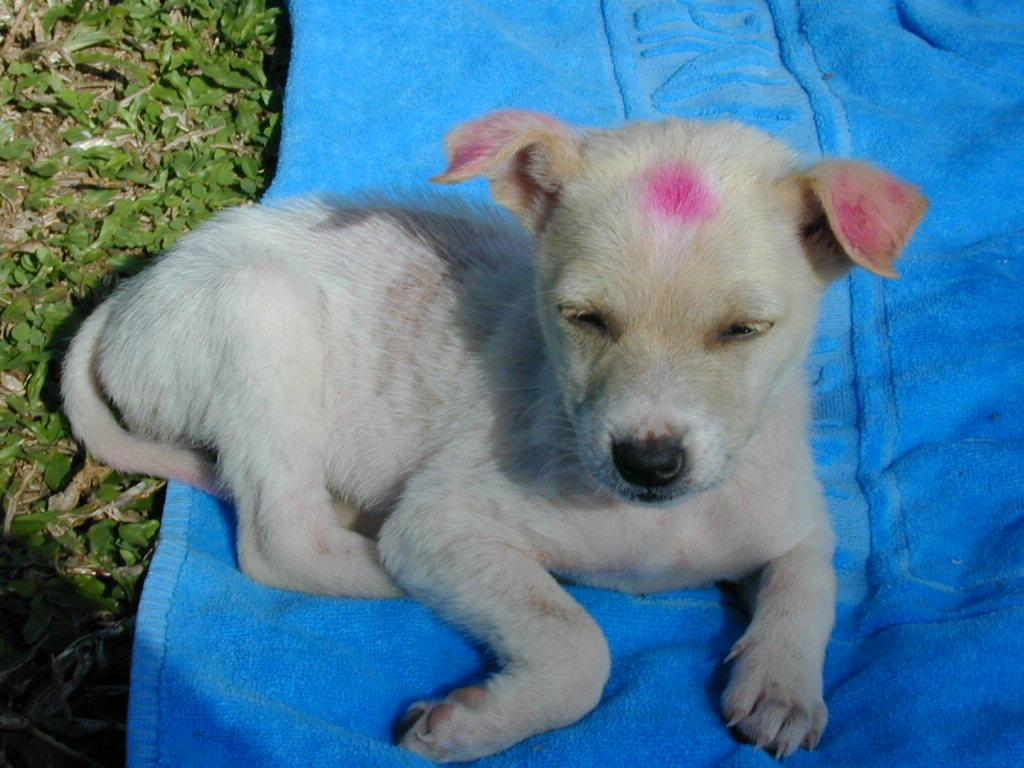What type of animal is in the image? There is a white color puppy in the image. What is the puppy laying on? The puppy is laying on a blue color cloth. Where is the cloth placed? The cloth is placed on the ground. What can be seen on the ground on the left side of the image? There are leaves on the ground on the left side of the image. What type of sponge is being used by the puppy to sleep in the image? There is no sponge present in the image, and the puppy is not shown sleeping. 